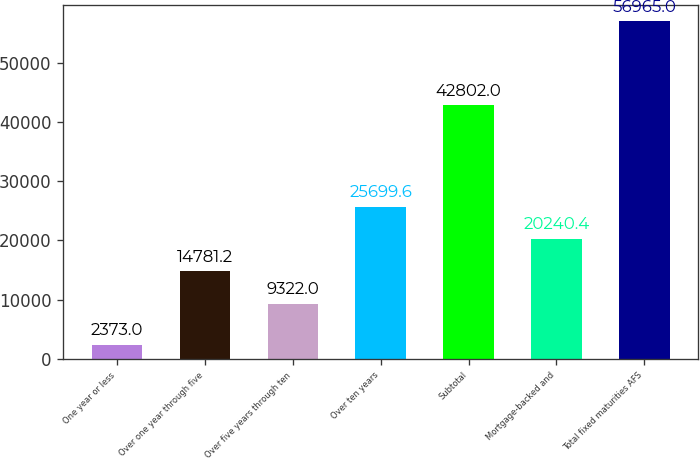Convert chart to OTSL. <chart><loc_0><loc_0><loc_500><loc_500><bar_chart><fcel>One year or less<fcel>Over one year through five<fcel>Over five years through ten<fcel>Over ten years<fcel>Subtotal<fcel>Mortgage-backed and<fcel>Total fixed maturities AFS<nl><fcel>2373<fcel>14781.2<fcel>9322<fcel>25699.6<fcel>42802<fcel>20240.4<fcel>56965<nl></chart> 